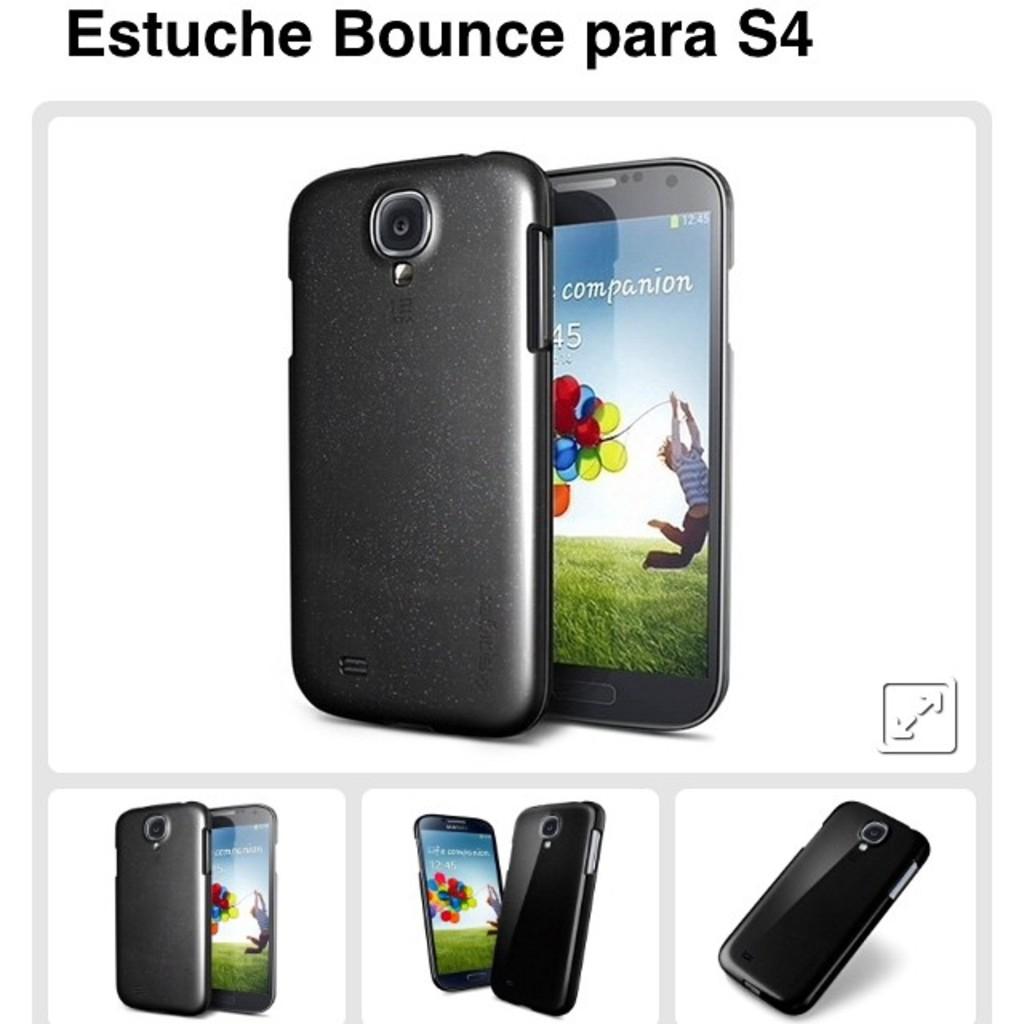What does the screen say?
Your response must be concise. Companion. 